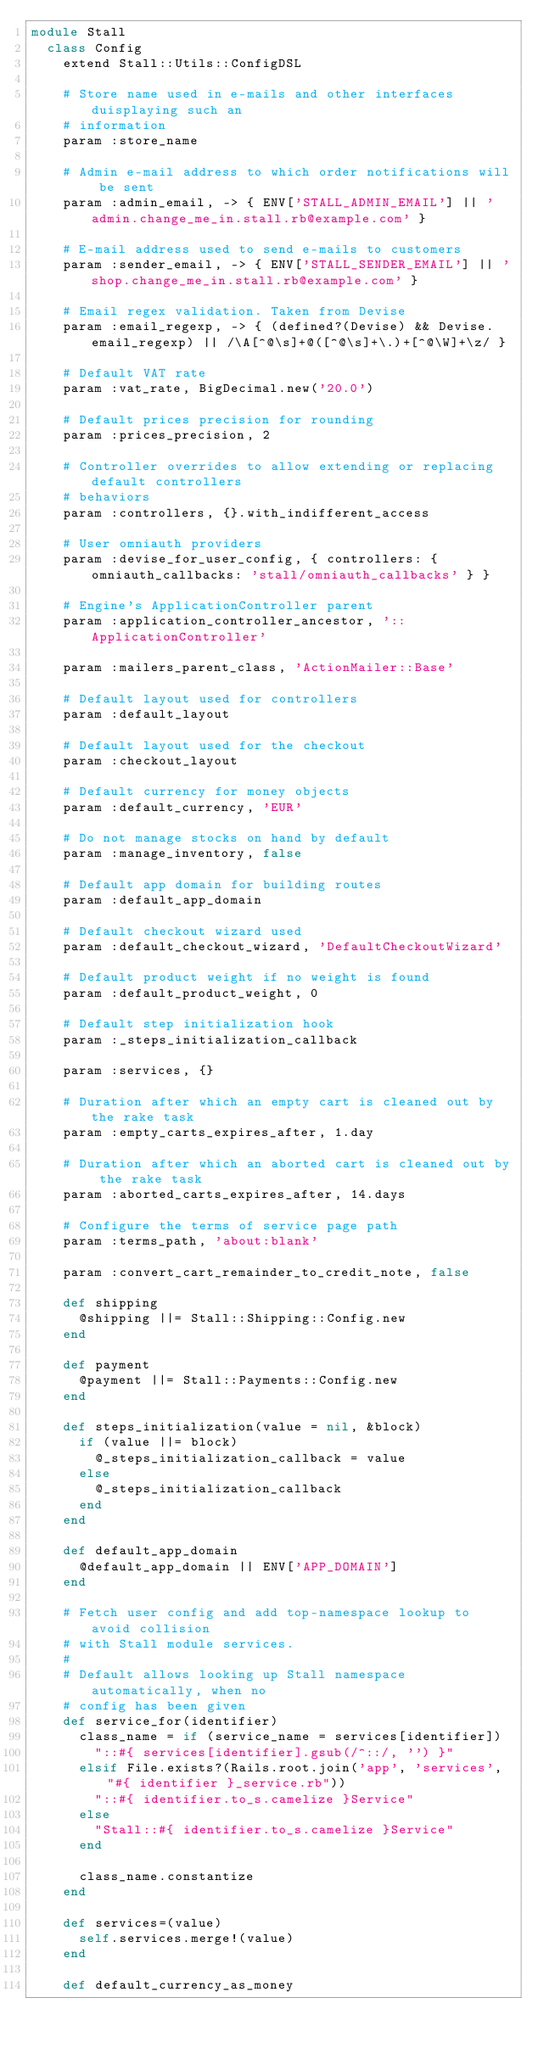<code> <loc_0><loc_0><loc_500><loc_500><_Ruby_>module Stall
  class Config
    extend Stall::Utils::ConfigDSL

    # Store name used in e-mails and other interfaces duisplaying such an
    # information
    param :store_name

    # Admin e-mail address to which order notifications will be sent
    param :admin_email, -> { ENV['STALL_ADMIN_EMAIL'] || 'admin.change_me_in.stall.rb@example.com' }

    # E-mail address used to send e-mails to customers
    param :sender_email, -> { ENV['STALL_SENDER_EMAIL'] || 'shop.change_me_in.stall.rb@example.com' }

    # Email regex validation. Taken from Devise
    param :email_regexp, -> { (defined?(Devise) && Devise.email_regexp) || /\A[^@\s]+@([^@\s]+\.)+[^@\W]+\z/ }

    # Default VAT rate
    param :vat_rate, BigDecimal.new('20.0')

    # Default prices precision for rounding
    param :prices_precision, 2

    # Controller overrides to allow extending or replacing default controllers
    # behaviors
    param :controllers, {}.with_indifferent_access

    # User omniauth providers
    param :devise_for_user_config, { controllers: { omniauth_callbacks: 'stall/omniauth_callbacks' } }

    # Engine's ApplicationController parent
    param :application_controller_ancestor, '::ApplicationController'

    param :mailers_parent_class, 'ActionMailer::Base'

    # Default layout used for controllers
    param :default_layout

    # Default layout used for the checkout
    param :checkout_layout

    # Default currency for money objects
    param :default_currency, 'EUR'

    # Do not manage stocks on hand by default
    param :manage_inventory, false

    # Default app domain for building routes
    param :default_app_domain

    # Default checkout wizard used
    param :default_checkout_wizard, 'DefaultCheckoutWizard'

    # Default product weight if no weight is found
    param :default_product_weight, 0

    # Default step initialization hook
    param :_steps_initialization_callback

    param :services, {}

    # Duration after which an empty cart is cleaned out by the rake task
    param :empty_carts_expires_after, 1.day

    # Duration after which an aborted cart is cleaned out by the rake task
    param :aborted_carts_expires_after, 14.days

    # Configure the terms of service page path
    param :terms_path, 'about:blank'

    param :convert_cart_remainder_to_credit_note, false

    def shipping
      @shipping ||= Stall::Shipping::Config.new
    end

    def payment
      @payment ||= Stall::Payments::Config.new
    end

    def steps_initialization(value = nil, &block)
      if (value ||= block)
        @_steps_initialization_callback = value
      else
        @_steps_initialization_callback
      end
    end

    def default_app_domain
      @default_app_domain || ENV['APP_DOMAIN']
    end

    # Fetch user config and add top-namespace lookup to avoid collision
    # with Stall module services.
    #
    # Default allows looking up Stall namespace automatically, when no
    # config has been given
    def service_for(identifier)
      class_name = if (service_name = services[identifier])
        "::#{ services[identifier].gsub(/^::/, '') }"
      elsif File.exists?(Rails.root.join('app', 'services', "#{ identifier }_service.rb"))
        "::#{ identifier.to_s.camelize }Service"
      else
        "Stall::#{ identifier.to_s.camelize }Service"
      end

      class_name.constantize
    end

    def services=(value)
      self.services.merge!(value)
    end

    def default_currency_as_money</code> 